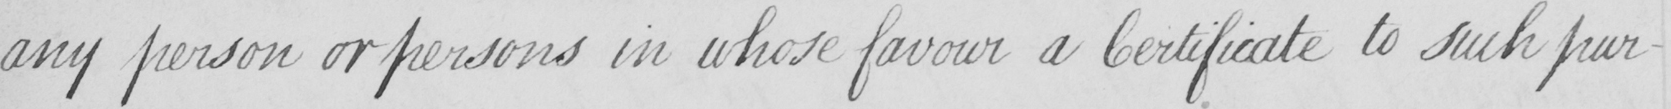What text is written in this handwritten line? any person or persons in whose favour a Certificate to such pur- 